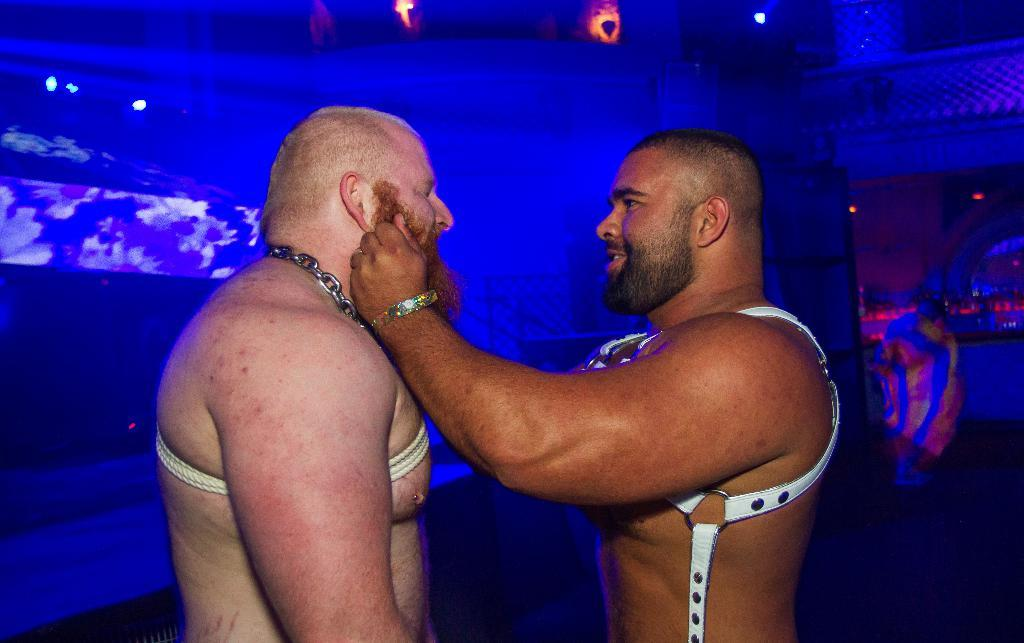How many people are in the image? There are two people in the image. What is the person on the right doing? The person on the right is standing and holding the beard of the person in front of them. What color is the background of the image? The background of the image is blue in color. What type of hill can be seen in the background of the image? There is no hill visible in the image; the background is blue in color. 